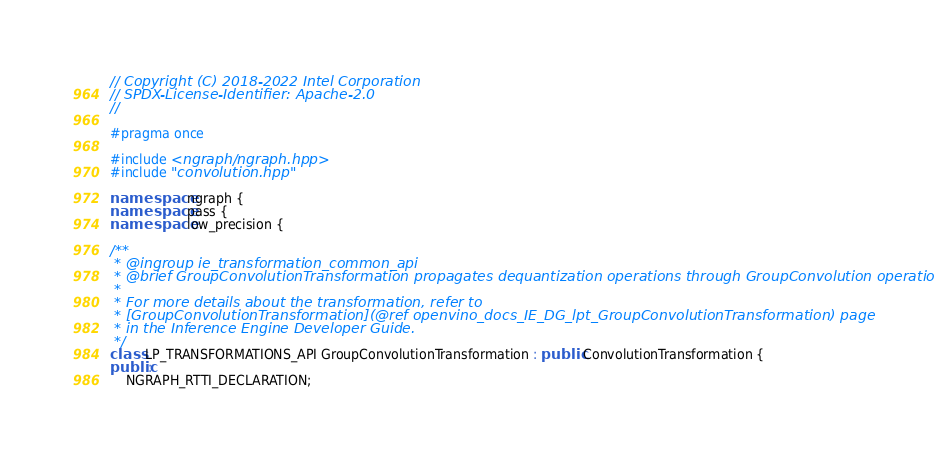Convert code to text. <code><loc_0><loc_0><loc_500><loc_500><_C++_>// Copyright (C) 2018-2022 Intel Corporation
// SPDX-License-Identifier: Apache-2.0
//

#pragma once

#include <ngraph/ngraph.hpp>
#include "convolution.hpp"

namespace ngraph {
namespace pass {
namespace low_precision {

/**
 * @ingroup ie_transformation_common_api
 * @brief GroupConvolutionTransformation propagates dequantization operations through GroupConvolution operation.
 *
 * For more details about the transformation, refer to
 * [GroupConvolutionTransformation](@ref openvino_docs_IE_DG_lpt_GroupConvolutionTransformation) page
 * in the Inference Engine Developer Guide.
 */
class LP_TRANSFORMATIONS_API GroupConvolutionTransformation : public ConvolutionTransformation {
public:
    NGRAPH_RTTI_DECLARATION;</code> 